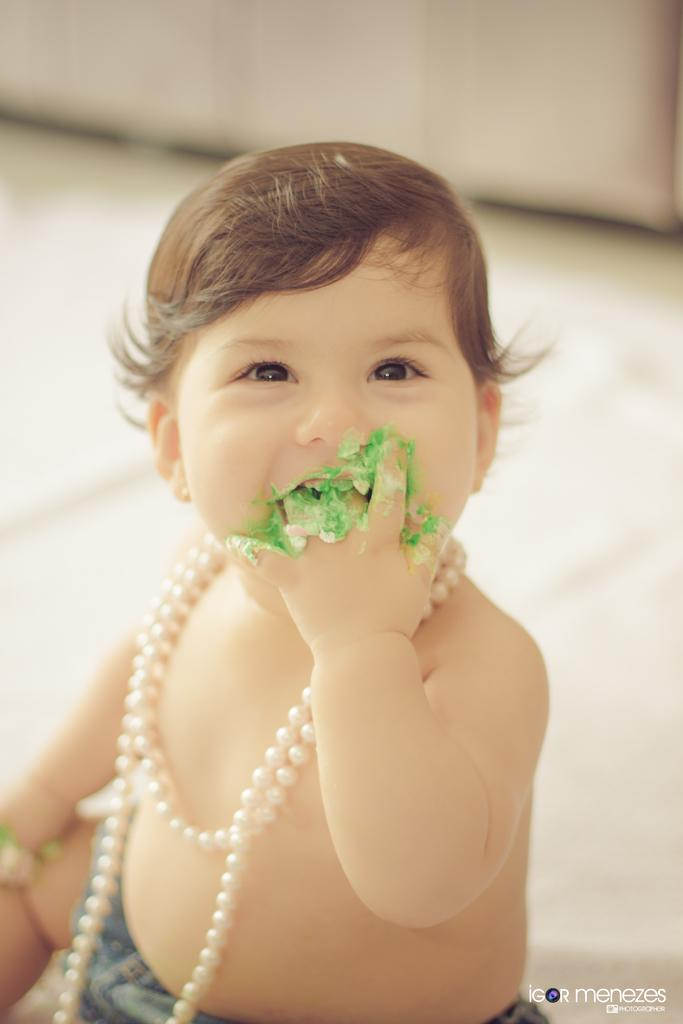Who or what is present in the image? There is a person in the image. What is the person doing or expressing? The person is smiling. Is there any text present in the image? Yes, there is text visible in the bottom right of the image. Can you describe the background of the image? The background of the image is blurry. How many dogs are visible in the image? There are no dogs present in the image. What type of mountain range can be seen in the background of the image? There is no mountain range visible in the image, as the background is blurry and does not show any specific geographical features. 